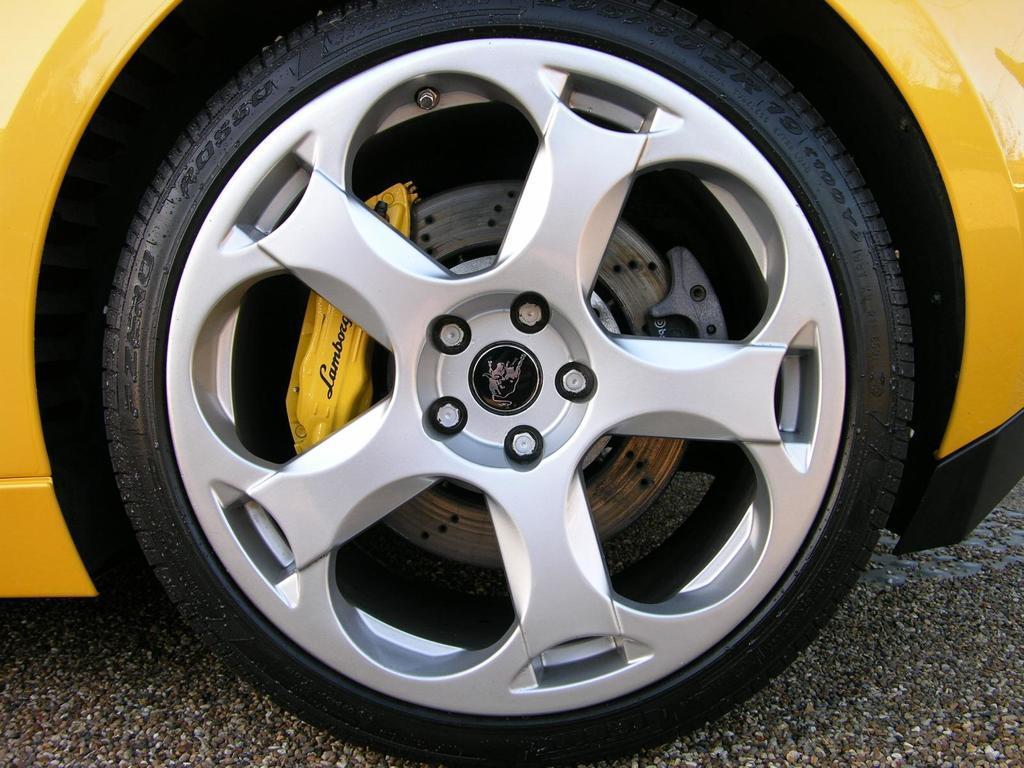Describe this image in one or two sentences. In the image there is a yellow color car with black tire. The car is on the road. 